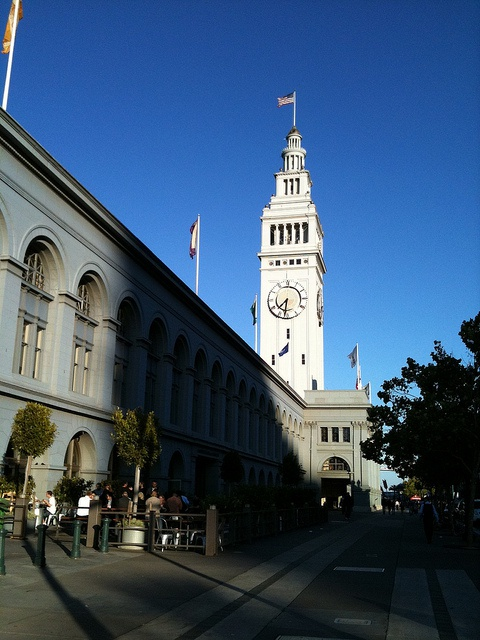Describe the objects in this image and their specific colors. I can see people in blue, black, gray, darkgray, and navy tones, clock in blue, ivory, darkgray, gray, and black tones, potted plant in blue, olive, tan, and beige tones, people in blue, black, gray, maroon, and tan tones, and people in blue, black, and gray tones in this image. 